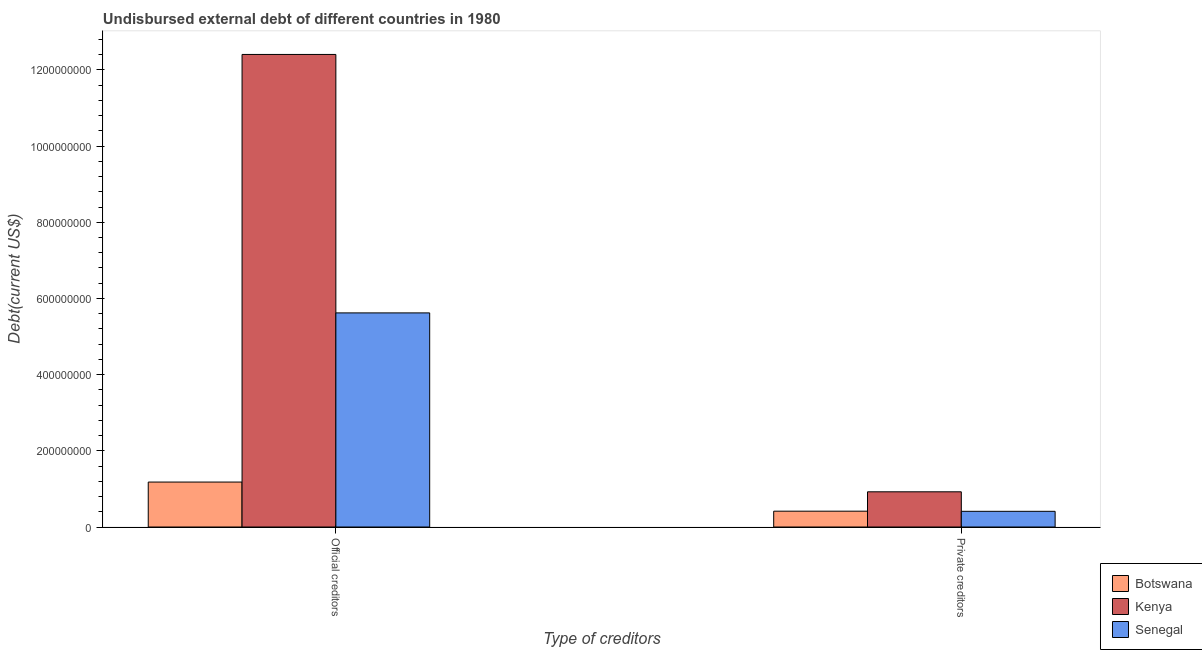Are the number of bars per tick equal to the number of legend labels?
Ensure brevity in your answer.  Yes. How many bars are there on the 1st tick from the left?
Make the answer very short. 3. How many bars are there on the 2nd tick from the right?
Give a very brief answer. 3. What is the label of the 2nd group of bars from the left?
Provide a short and direct response. Private creditors. What is the undisbursed external debt of official creditors in Senegal?
Provide a succinct answer. 5.62e+08. Across all countries, what is the maximum undisbursed external debt of private creditors?
Make the answer very short. 9.24e+07. Across all countries, what is the minimum undisbursed external debt of official creditors?
Your response must be concise. 1.18e+08. In which country was the undisbursed external debt of private creditors maximum?
Your response must be concise. Kenya. In which country was the undisbursed external debt of official creditors minimum?
Offer a terse response. Botswana. What is the total undisbursed external debt of official creditors in the graph?
Keep it short and to the point. 1.92e+09. What is the difference between the undisbursed external debt of private creditors in Botswana and that in Senegal?
Offer a terse response. 3.75e+05. What is the difference between the undisbursed external debt of official creditors in Kenya and the undisbursed external debt of private creditors in Botswana?
Give a very brief answer. 1.20e+09. What is the average undisbursed external debt of private creditors per country?
Provide a succinct answer. 5.84e+07. What is the difference between the undisbursed external debt of private creditors and undisbursed external debt of official creditors in Kenya?
Make the answer very short. -1.15e+09. What is the ratio of the undisbursed external debt of official creditors in Botswana to that in Kenya?
Ensure brevity in your answer.  0.1. In how many countries, is the undisbursed external debt of official creditors greater than the average undisbursed external debt of official creditors taken over all countries?
Provide a succinct answer. 1. What does the 1st bar from the left in Official creditors represents?
Provide a succinct answer. Botswana. What does the 3rd bar from the right in Private creditors represents?
Ensure brevity in your answer.  Botswana. How many bars are there?
Keep it short and to the point. 6. Are all the bars in the graph horizontal?
Give a very brief answer. No. How many countries are there in the graph?
Offer a terse response. 3. What is the difference between two consecutive major ticks on the Y-axis?
Offer a very short reply. 2.00e+08. Are the values on the major ticks of Y-axis written in scientific E-notation?
Give a very brief answer. No. Does the graph contain grids?
Offer a terse response. No. Where does the legend appear in the graph?
Your answer should be very brief. Bottom right. What is the title of the graph?
Ensure brevity in your answer.  Undisbursed external debt of different countries in 1980. What is the label or title of the X-axis?
Your answer should be compact. Type of creditors. What is the label or title of the Y-axis?
Make the answer very short. Debt(current US$). What is the Debt(current US$) of Botswana in Official creditors?
Keep it short and to the point. 1.18e+08. What is the Debt(current US$) in Kenya in Official creditors?
Provide a succinct answer. 1.24e+09. What is the Debt(current US$) in Senegal in Official creditors?
Ensure brevity in your answer.  5.62e+08. What is the Debt(current US$) in Botswana in Private creditors?
Ensure brevity in your answer.  4.16e+07. What is the Debt(current US$) in Kenya in Private creditors?
Make the answer very short. 9.24e+07. What is the Debt(current US$) in Senegal in Private creditors?
Make the answer very short. 4.12e+07. Across all Type of creditors, what is the maximum Debt(current US$) of Botswana?
Ensure brevity in your answer.  1.18e+08. Across all Type of creditors, what is the maximum Debt(current US$) in Kenya?
Your response must be concise. 1.24e+09. Across all Type of creditors, what is the maximum Debt(current US$) in Senegal?
Offer a very short reply. 5.62e+08. Across all Type of creditors, what is the minimum Debt(current US$) in Botswana?
Provide a succinct answer. 4.16e+07. Across all Type of creditors, what is the minimum Debt(current US$) of Kenya?
Make the answer very short. 9.24e+07. Across all Type of creditors, what is the minimum Debt(current US$) in Senegal?
Provide a succinct answer. 4.12e+07. What is the total Debt(current US$) in Botswana in the graph?
Provide a succinct answer. 1.60e+08. What is the total Debt(current US$) in Kenya in the graph?
Ensure brevity in your answer.  1.33e+09. What is the total Debt(current US$) in Senegal in the graph?
Keep it short and to the point. 6.03e+08. What is the difference between the Debt(current US$) of Botswana in Official creditors and that in Private creditors?
Provide a short and direct response. 7.64e+07. What is the difference between the Debt(current US$) in Kenya in Official creditors and that in Private creditors?
Give a very brief answer. 1.15e+09. What is the difference between the Debt(current US$) of Senegal in Official creditors and that in Private creditors?
Your answer should be compact. 5.21e+08. What is the difference between the Debt(current US$) of Botswana in Official creditors and the Debt(current US$) of Kenya in Private creditors?
Your response must be concise. 2.56e+07. What is the difference between the Debt(current US$) of Botswana in Official creditors and the Debt(current US$) of Senegal in Private creditors?
Offer a very short reply. 7.68e+07. What is the difference between the Debt(current US$) of Kenya in Official creditors and the Debt(current US$) of Senegal in Private creditors?
Ensure brevity in your answer.  1.20e+09. What is the average Debt(current US$) in Botswana per Type of creditors?
Provide a succinct answer. 7.98e+07. What is the average Debt(current US$) in Kenya per Type of creditors?
Provide a succinct answer. 6.66e+08. What is the average Debt(current US$) in Senegal per Type of creditors?
Make the answer very short. 3.02e+08. What is the difference between the Debt(current US$) in Botswana and Debt(current US$) in Kenya in Official creditors?
Offer a terse response. -1.12e+09. What is the difference between the Debt(current US$) in Botswana and Debt(current US$) in Senegal in Official creditors?
Provide a succinct answer. -4.44e+08. What is the difference between the Debt(current US$) of Kenya and Debt(current US$) of Senegal in Official creditors?
Keep it short and to the point. 6.78e+08. What is the difference between the Debt(current US$) of Botswana and Debt(current US$) of Kenya in Private creditors?
Provide a succinct answer. -5.09e+07. What is the difference between the Debt(current US$) in Botswana and Debt(current US$) in Senegal in Private creditors?
Provide a succinct answer. 3.75e+05. What is the difference between the Debt(current US$) of Kenya and Debt(current US$) of Senegal in Private creditors?
Your response must be concise. 5.12e+07. What is the ratio of the Debt(current US$) in Botswana in Official creditors to that in Private creditors?
Keep it short and to the point. 2.84. What is the ratio of the Debt(current US$) in Kenya in Official creditors to that in Private creditors?
Provide a succinct answer. 13.42. What is the ratio of the Debt(current US$) of Senegal in Official creditors to that in Private creditors?
Offer a very short reply. 13.65. What is the difference between the highest and the second highest Debt(current US$) in Botswana?
Provide a short and direct response. 7.64e+07. What is the difference between the highest and the second highest Debt(current US$) of Kenya?
Provide a succinct answer. 1.15e+09. What is the difference between the highest and the second highest Debt(current US$) of Senegal?
Your answer should be compact. 5.21e+08. What is the difference between the highest and the lowest Debt(current US$) of Botswana?
Your answer should be very brief. 7.64e+07. What is the difference between the highest and the lowest Debt(current US$) of Kenya?
Offer a very short reply. 1.15e+09. What is the difference between the highest and the lowest Debt(current US$) in Senegal?
Provide a succinct answer. 5.21e+08. 